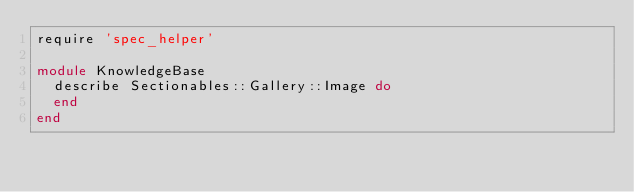Convert code to text. <code><loc_0><loc_0><loc_500><loc_500><_Ruby_>require 'spec_helper'

module KnowledgeBase
  describe Sectionables::Gallery::Image do
  end
end
</code> 